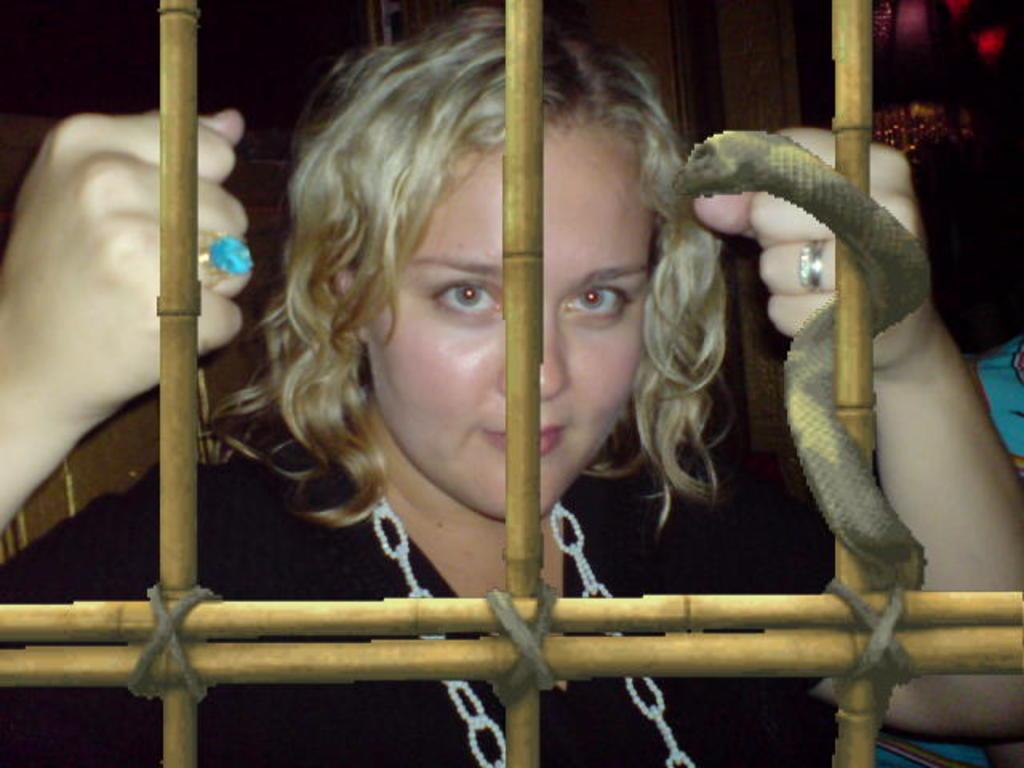Who is the main subject in the image? There is a woman in the image. What is the woman wearing on her right hand? The woman is wearing a blue ring on her right hand. What color is the dress the woman is wearing? The woman is wearing a black dress. What type of fiction is the woman reading in the image? There is no book or any indication of reading in the image, so it cannot be determined if the woman is reading fiction or any other type of material. 